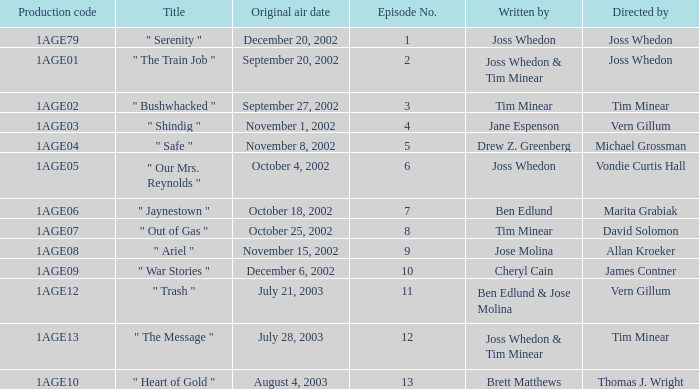What is the production code for the episode written by Drew Z. Greenberg? 1AGE04. Could you parse the entire table? {'header': ['Production code', 'Title', 'Original air date', 'Episode No.', 'Written by', 'Directed by'], 'rows': [['1AGE79', '" Serenity "', 'December 20, 2002', '1', 'Joss Whedon', 'Joss Whedon'], ['1AGE01', '" The Train Job "', 'September 20, 2002', '2', 'Joss Whedon & Tim Minear', 'Joss Whedon'], ['1AGE02', '" Bushwhacked "', 'September 27, 2002', '3', 'Tim Minear', 'Tim Minear'], ['1AGE03', '" Shindig "', 'November 1, 2002', '4', 'Jane Espenson', 'Vern Gillum'], ['1AGE04', '" Safe "', 'November 8, 2002', '5', 'Drew Z. Greenberg', 'Michael Grossman'], ['1AGE05', '" Our Mrs. Reynolds "', 'October 4, 2002', '6', 'Joss Whedon', 'Vondie Curtis Hall'], ['1AGE06', '" Jaynestown "', 'October 18, 2002', '7', 'Ben Edlund', 'Marita Grabiak'], ['1AGE07', '" Out of Gas "', 'October 25, 2002', '8', 'Tim Minear', 'David Solomon'], ['1AGE08', '" Ariel "', 'November 15, 2002', '9', 'Jose Molina', 'Allan Kroeker'], ['1AGE09', '" War Stories "', 'December 6, 2002', '10', 'Cheryl Cain', 'James Contner'], ['1AGE12', '" Trash "', 'July 21, 2003', '11', 'Ben Edlund & Jose Molina', 'Vern Gillum'], ['1AGE13', '" The Message "', 'July 28, 2003', '12', 'Joss Whedon & Tim Minear', 'Tim Minear'], ['1AGE10', '" Heart of Gold "', 'August 4, 2003', '13', 'Brett Matthews', 'Thomas J. Wright']]} 